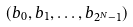<formula> <loc_0><loc_0><loc_500><loc_500>( b _ { 0 } , b _ { 1 } , \dots , b _ { 2 ^ { N } - 1 } )</formula> 